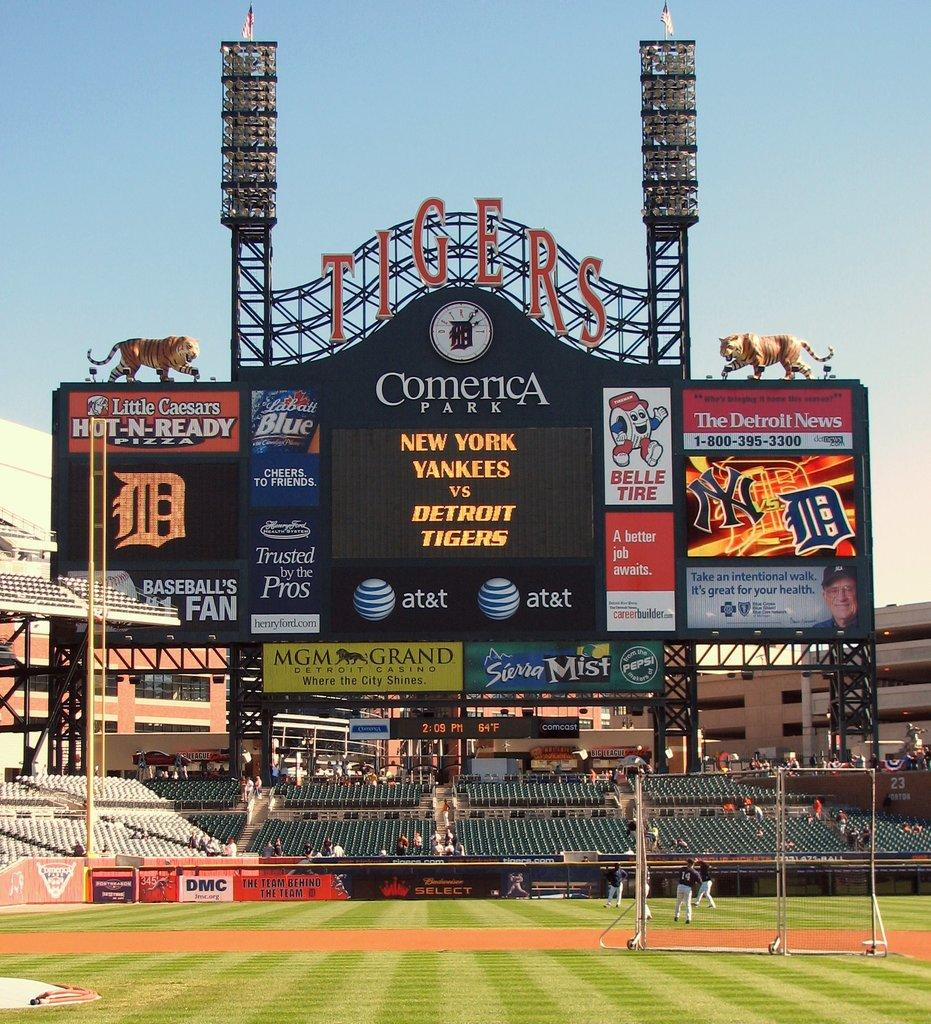<image>
Give a short and clear explanation of the subsequent image. The teams playing baseball are the Yankees and Tigers. 